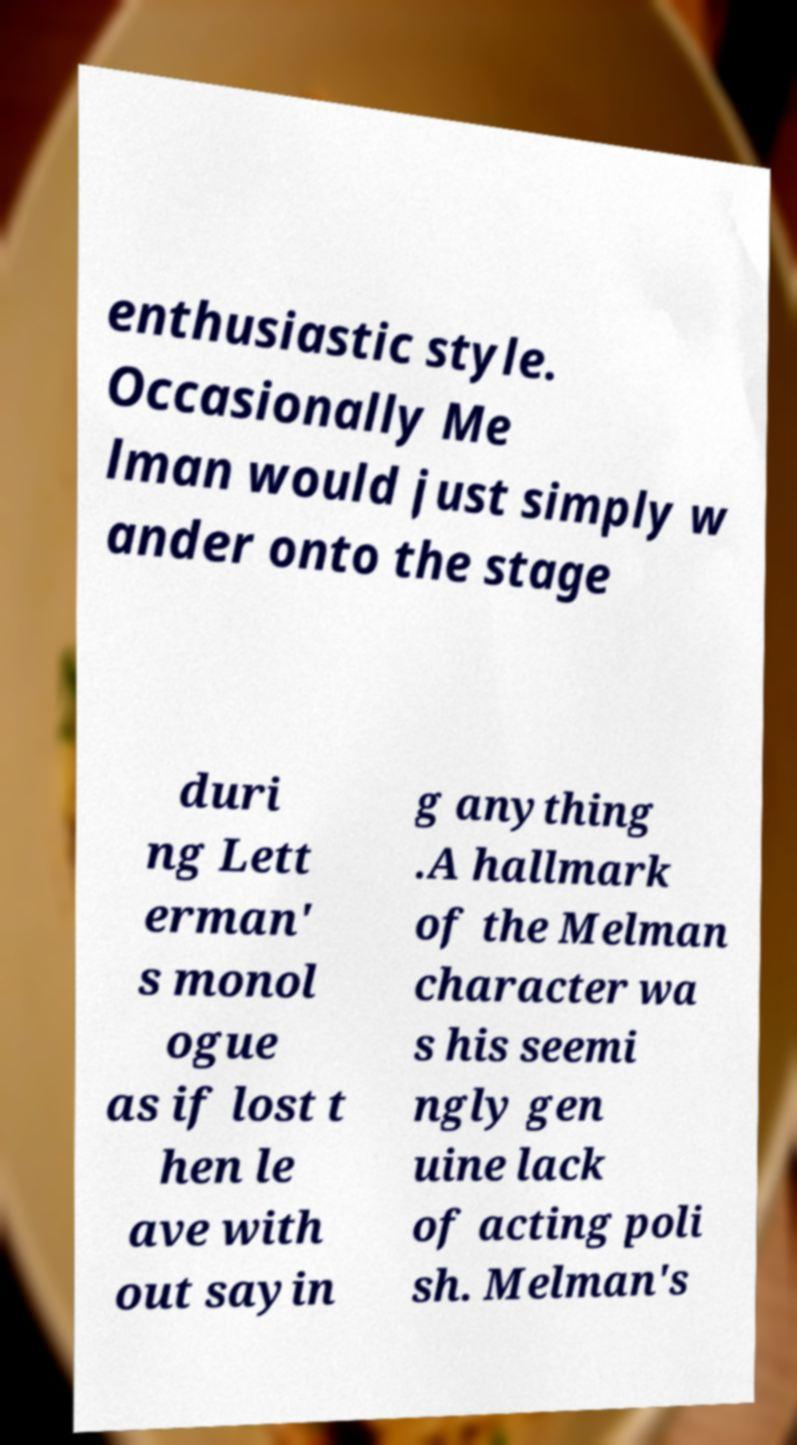There's text embedded in this image that I need extracted. Can you transcribe it verbatim? enthusiastic style. Occasionally Me lman would just simply w ander onto the stage duri ng Lett erman' s monol ogue as if lost t hen le ave with out sayin g anything .A hallmark of the Melman character wa s his seemi ngly gen uine lack of acting poli sh. Melman's 